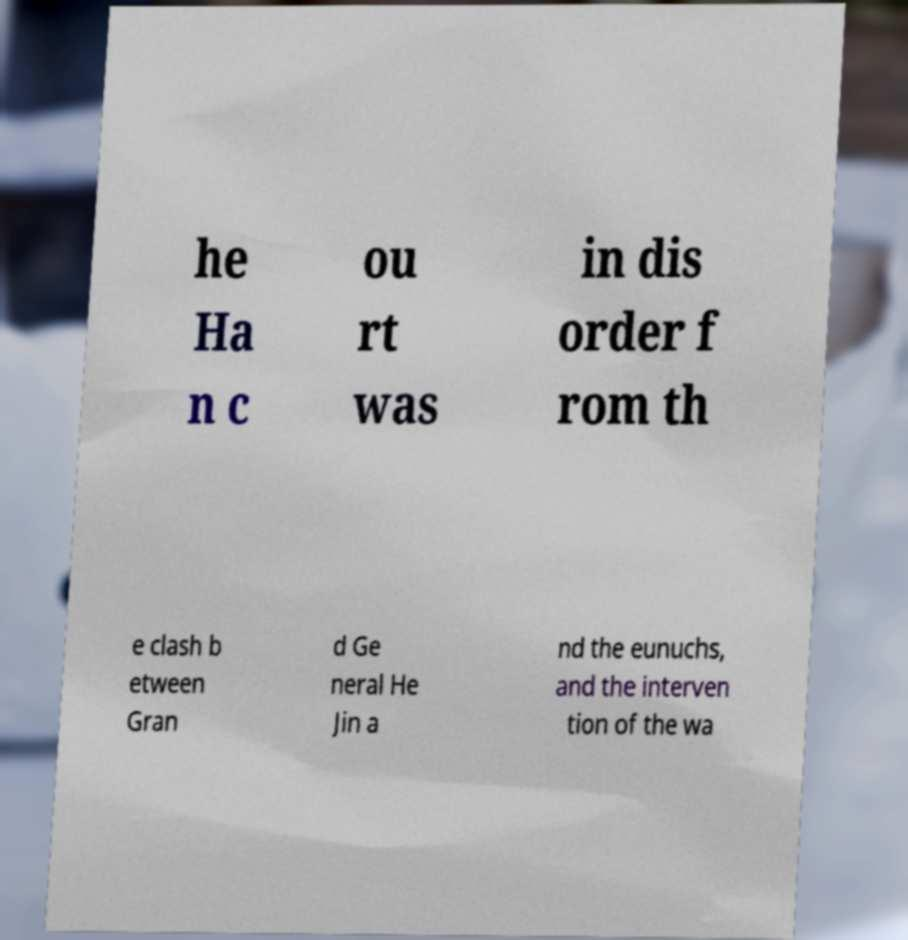Could you assist in decoding the text presented in this image and type it out clearly? he Ha n c ou rt was in dis order f rom th e clash b etween Gran d Ge neral He Jin a nd the eunuchs, and the interven tion of the wa 